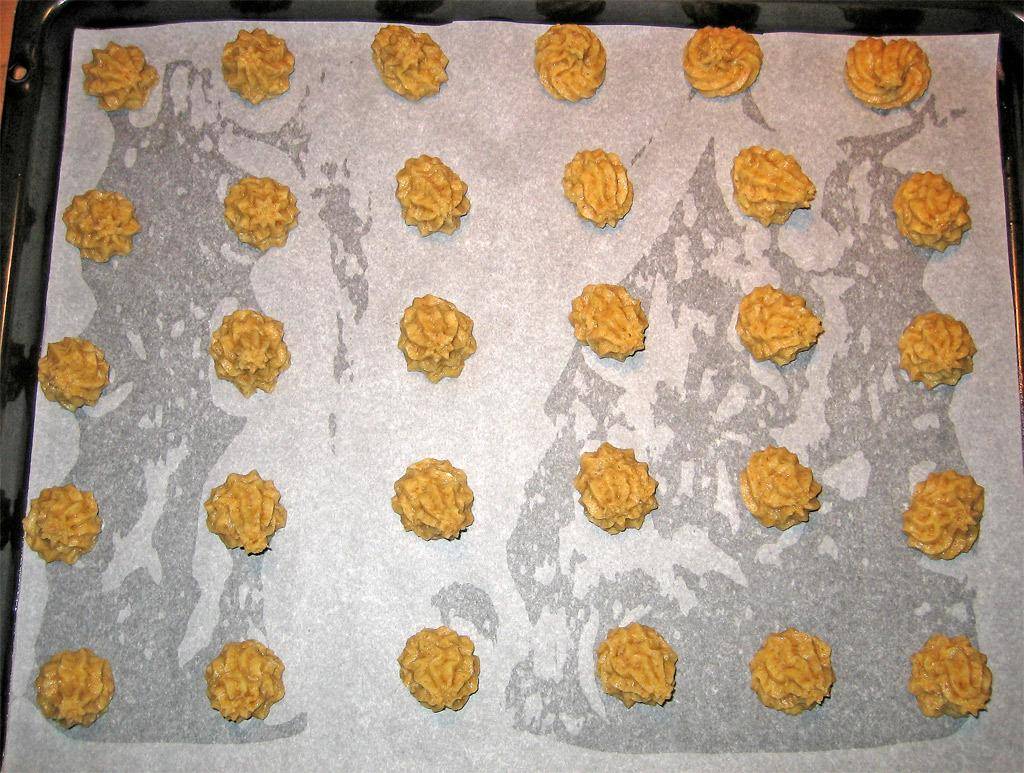What is the primary object in the image? There is a white paper in the image. What can be seen on the white paper? There are brown things on the white paper. What is the color of the surface beneath the white paper? The white paper is on a black surface. What type of farmer is depicted on the white paper? There is no farmer depicted on the white paper; it only shows brown things on a white paper. What religious belief is represented by the brown things on the white paper? There is no religious belief represented by the brown things on the white paper; they are simply objects or shapes on a white paper. 